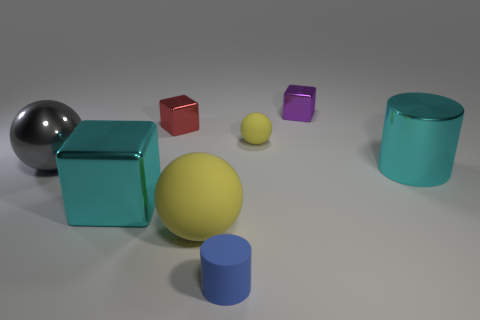Add 2 tiny rubber cylinders. How many objects exist? 10 Subtract all cubes. How many objects are left? 5 Add 2 large gray spheres. How many large gray spheres are left? 3 Add 3 cyan shiny blocks. How many cyan shiny blocks exist? 4 Subtract 0 cyan spheres. How many objects are left? 8 Subtract all tiny blue rubber things. Subtract all gray spheres. How many objects are left? 6 